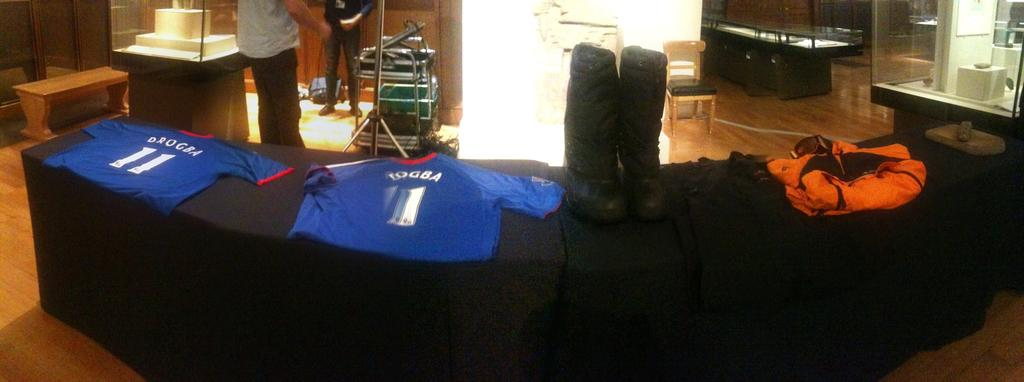<image>
Describe the image concisely. A couple of blue shirts on a table with one says Drogba  and Togba 